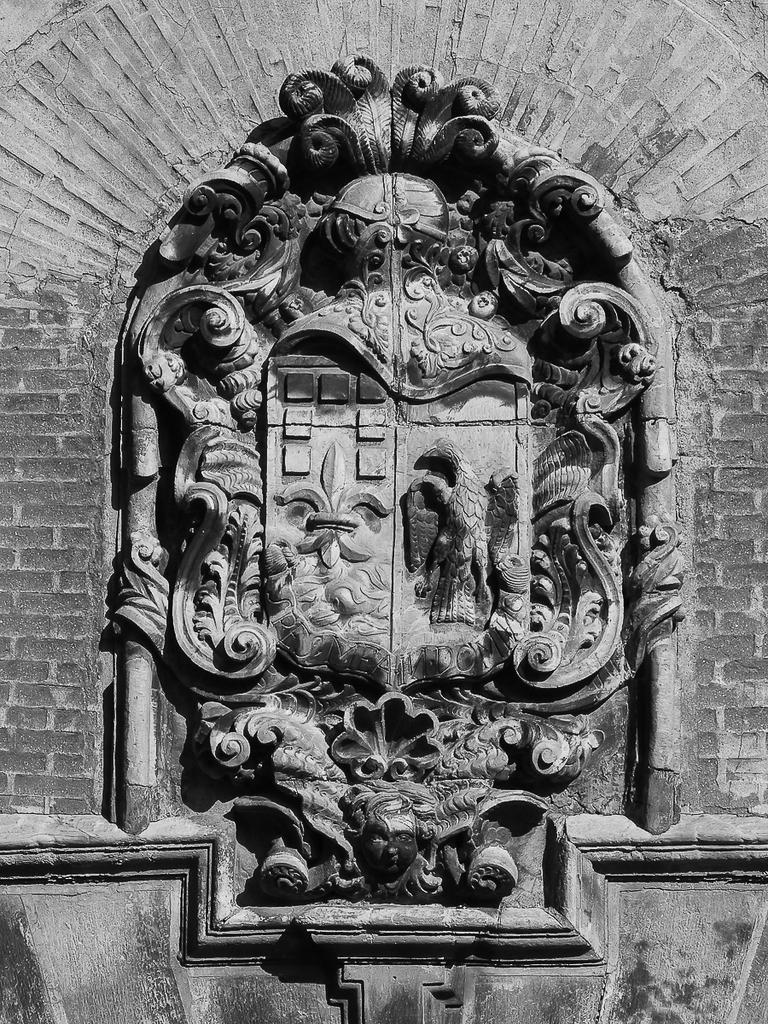Can you describe this image briefly? In this picture there is a floral sculpture and there is a sculpture of a bird on the wall. 